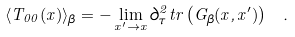Convert formula to latex. <formula><loc_0><loc_0><loc_500><loc_500>\langle T _ { 0 0 } ( x ) \rangle _ { \beta } = - \lim _ { x ^ { \prime } \rightarrow x } \partial _ { \tau } ^ { 2 } t r \left ( G _ { \beta } ( x , x ^ { \prime } ) \right ) \ .</formula> 